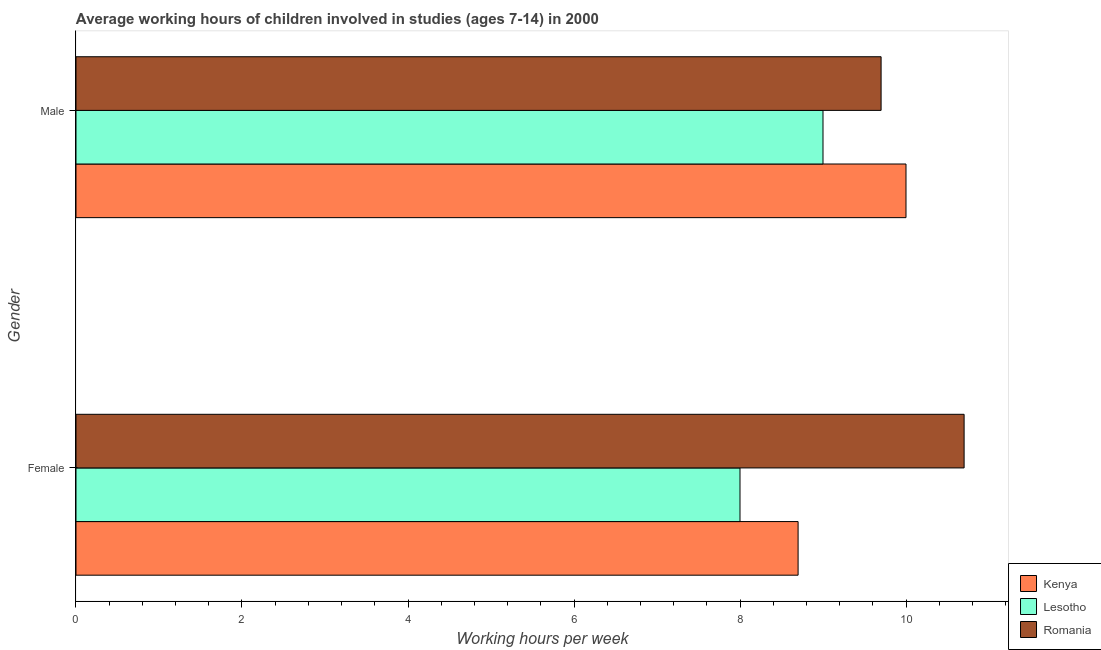How many different coloured bars are there?
Ensure brevity in your answer.  3. How many bars are there on the 2nd tick from the top?
Your response must be concise. 3. How many bars are there on the 1st tick from the bottom?
Give a very brief answer. 3. In which country was the average working hour of male children maximum?
Your response must be concise. Kenya. In which country was the average working hour of female children minimum?
Provide a short and direct response. Lesotho. What is the total average working hour of female children in the graph?
Provide a succinct answer. 27.4. What is the difference between the average working hour of female children in Lesotho and the average working hour of male children in Romania?
Your answer should be very brief. -1.7. What is the average average working hour of female children per country?
Keep it short and to the point. 9.13. In how many countries, is the average working hour of male children greater than 3.6 hours?
Provide a succinct answer. 3. What is the ratio of the average working hour of female children in Lesotho to that in Romania?
Make the answer very short. 0.75. What does the 3rd bar from the top in Female represents?
Offer a very short reply. Kenya. What does the 2nd bar from the bottom in Male represents?
Your response must be concise. Lesotho. How many bars are there?
Offer a very short reply. 6. Are all the bars in the graph horizontal?
Your answer should be very brief. Yes. How many countries are there in the graph?
Give a very brief answer. 3. Are the values on the major ticks of X-axis written in scientific E-notation?
Provide a short and direct response. No. Does the graph contain any zero values?
Your answer should be compact. No. Does the graph contain grids?
Ensure brevity in your answer.  No. Where does the legend appear in the graph?
Offer a very short reply. Bottom right. What is the title of the graph?
Make the answer very short. Average working hours of children involved in studies (ages 7-14) in 2000. What is the label or title of the X-axis?
Provide a succinct answer. Working hours per week. What is the Working hours per week in Kenya in Female?
Give a very brief answer. 8.7. What is the Working hours per week in Kenya in Male?
Provide a short and direct response. 10. What is the Working hours per week of Lesotho in Male?
Make the answer very short. 9. Across all Gender, what is the minimum Working hours per week of Lesotho?
Offer a terse response. 8. What is the total Working hours per week of Lesotho in the graph?
Ensure brevity in your answer.  17. What is the total Working hours per week in Romania in the graph?
Keep it short and to the point. 20.4. What is the difference between the Working hours per week in Lesotho in Female and that in Male?
Offer a very short reply. -1. What is the difference between the Working hours per week in Kenya in Female and the Working hours per week in Lesotho in Male?
Ensure brevity in your answer.  -0.3. What is the difference between the Working hours per week in Kenya in Female and the Working hours per week in Romania in Male?
Your answer should be compact. -1. What is the difference between the Working hours per week of Lesotho in Female and the Working hours per week of Romania in Male?
Make the answer very short. -1.7. What is the average Working hours per week of Kenya per Gender?
Keep it short and to the point. 9.35. What is the average Working hours per week of Romania per Gender?
Provide a succinct answer. 10.2. What is the difference between the Working hours per week of Kenya and Working hours per week of Romania in Female?
Ensure brevity in your answer.  -2. What is the difference between the Working hours per week in Lesotho and Working hours per week in Romania in Female?
Your answer should be compact. -2.7. What is the difference between the Working hours per week of Kenya and Working hours per week of Romania in Male?
Your response must be concise. 0.3. What is the ratio of the Working hours per week in Kenya in Female to that in Male?
Provide a succinct answer. 0.87. What is the ratio of the Working hours per week of Lesotho in Female to that in Male?
Give a very brief answer. 0.89. What is the ratio of the Working hours per week in Romania in Female to that in Male?
Give a very brief answer. 1.1. What is the difference between the highest and the second highest Working hours per week of Lesotho?
Your response must be concise. 1. What is the difference between the highest and the second highest Working hours per week of Romania?
Your response must be concise. 1. What is the difference between the highest and the lowest Working hours per week of Romania?
Ensure brevity in your answer.  1. 